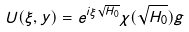<formula> <loc_0><loc_0><loc_500><loc_500>U ( \xi , y ) = e ^ { i \xi \sqrt { H _ { 0 } } } \chi ( \sqrt { H _ { 0 } } ) g</formula> 